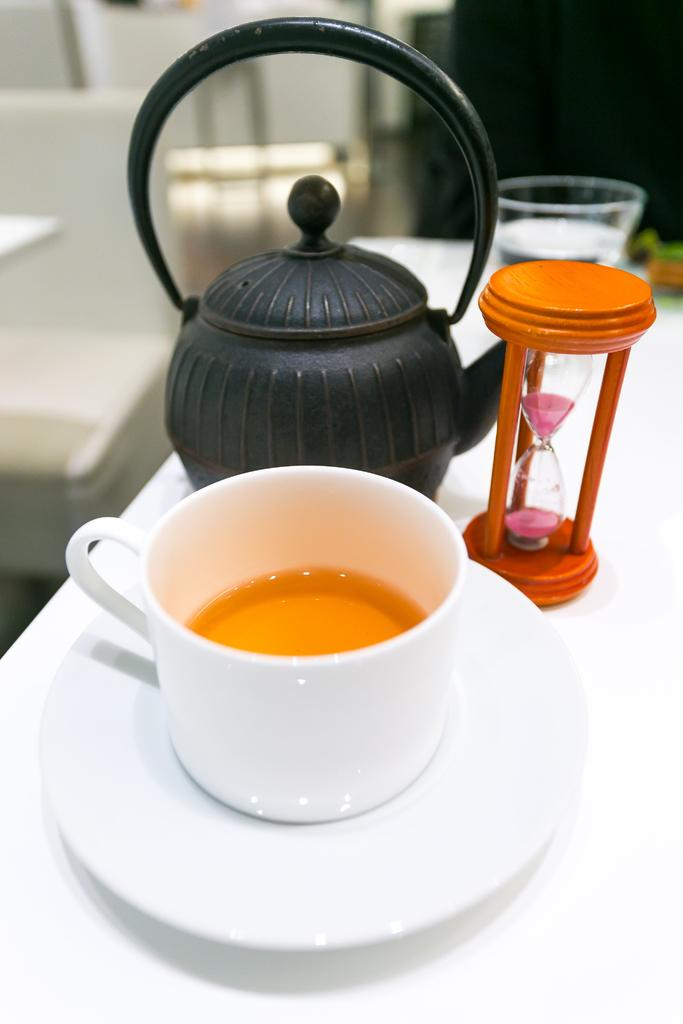What color is the teacup in the image? The teacup in the image is white. Where is the teacup placed in the image? The teacup is placed on a white table top. What other object can be seen in the image related to time? There is a sand clock in the image. What color is the kettle in the image? The kettle in the image is black. Can you describe the background of the image? The background of the image is blurred. Is the woman in the image holding a degree? There is no woman present in the image, and therefore no one is holding a degree. 